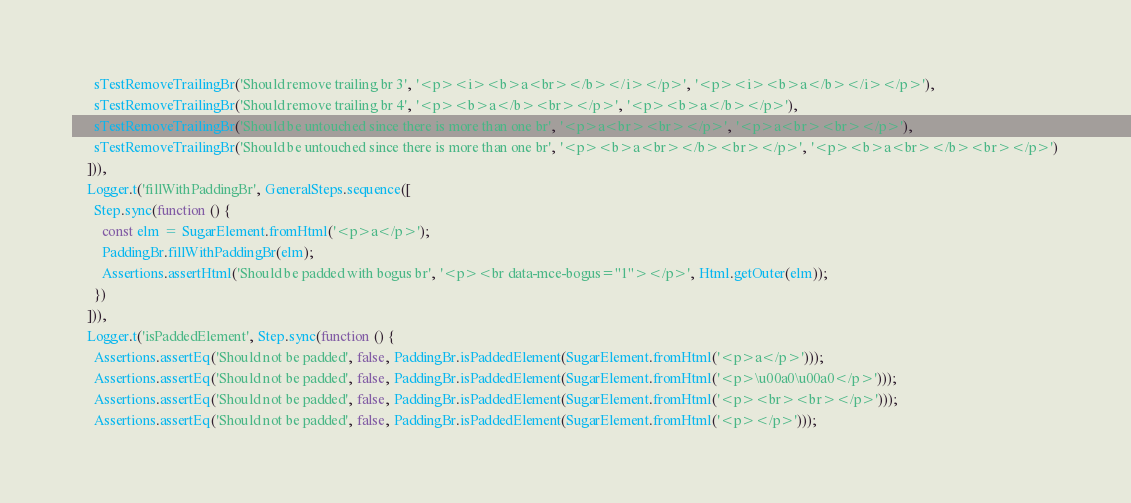<code> <loc_0><loc_0><loc_500><loc_500><_TypeScript_>      sTestRemoveTrailingBr('Should remove trailing br 3', '<p><i><b>a<br></b></i></p>', '<p><i><b>a</b></i></p>'),
      sTestRemoveTrailingBr('Should remove trailing br 4', '<p><b>a</b><br></p>', '<p><b>a</b></p>'),
      sTestRemoveTrailingBr('Should be untouched since there is more than one br', '<p>a<br><br></p>', '<p>a<br><br></p>'),
      sTestRemoveTrailingBr('Should be untouched since there is more than one br', '<p><b>a<br></b><br></p>', '<p><b>a<br></b><br></p>')
    ])),
    Logger.t('fillWithPaddingBr', GeneralSteps.sequence([
      Step.sync(function () {
        const elm = SugarElement.fromHtml('<p>a</p>');
        PaddingBr.fillWithPaddingBr(elm);
        Assertions.assertHtml('Should be padded with bogus br', '<p><br data-mce-bogus="1"></p>', Html.getOuter(elm));
      })
    ])),
    Logger.t('isPaddedElement', Step.sync(function () {
      Assertions.assertEq('Should not be padded', false, PaddingBr.isPaddedElement(SugarElement.fromHtml('<p>a</p>')));
      Assertions.assertEq('Should not be padded', false, PaddingBr.isPaddedElement(SugarElement.fromHtml('<p>\u00a0\u00a0</p>')));
      Assertions.assertEq('Should not be padded', false, PaddingBr.isPaddedElement(SugarElement.fromHtml('<p><br><br></p>')));
      Assertions.assertEq('Should not be padded', false, PaddingBr.isPaddedElement(SugarElement.fromHtml('<p></p>')));</code> 